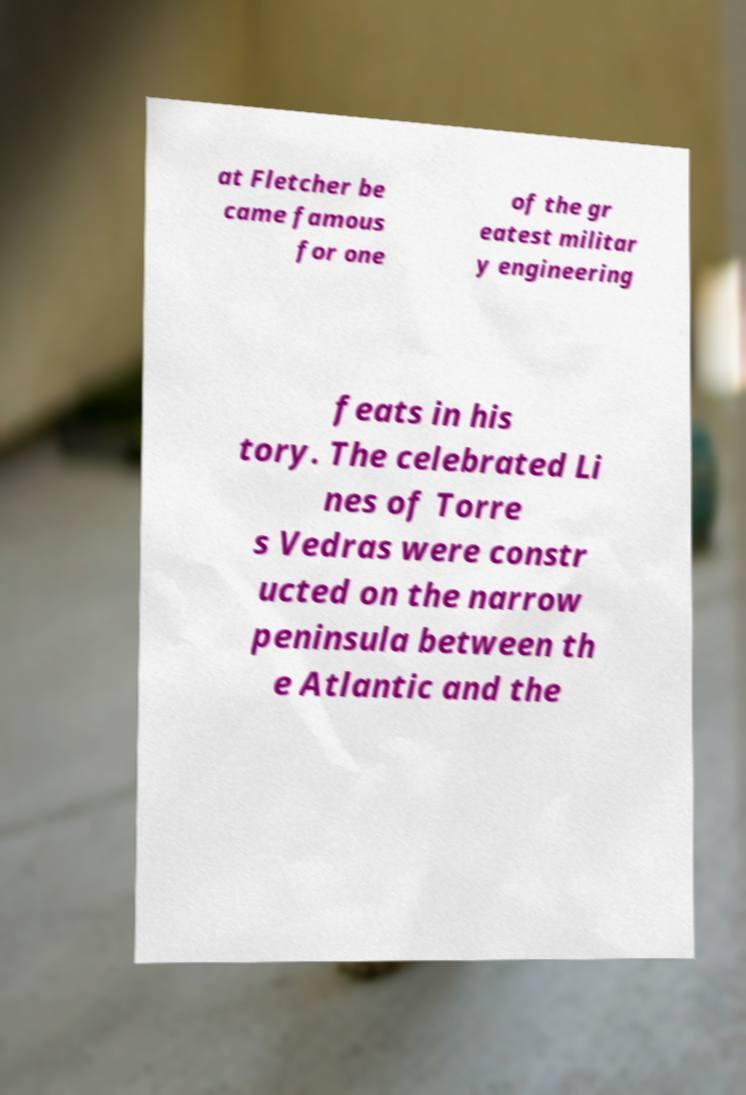There's text embedded in this image that I need extracted. Can you transcribe it verbatim? at Fletcher be came famous for one of the gr eatest militar y engineering feats in his tory. The celebrated Li nes of Torre s Vedras were constr ucted on the narrow peninsula between th e Atlantic and the 